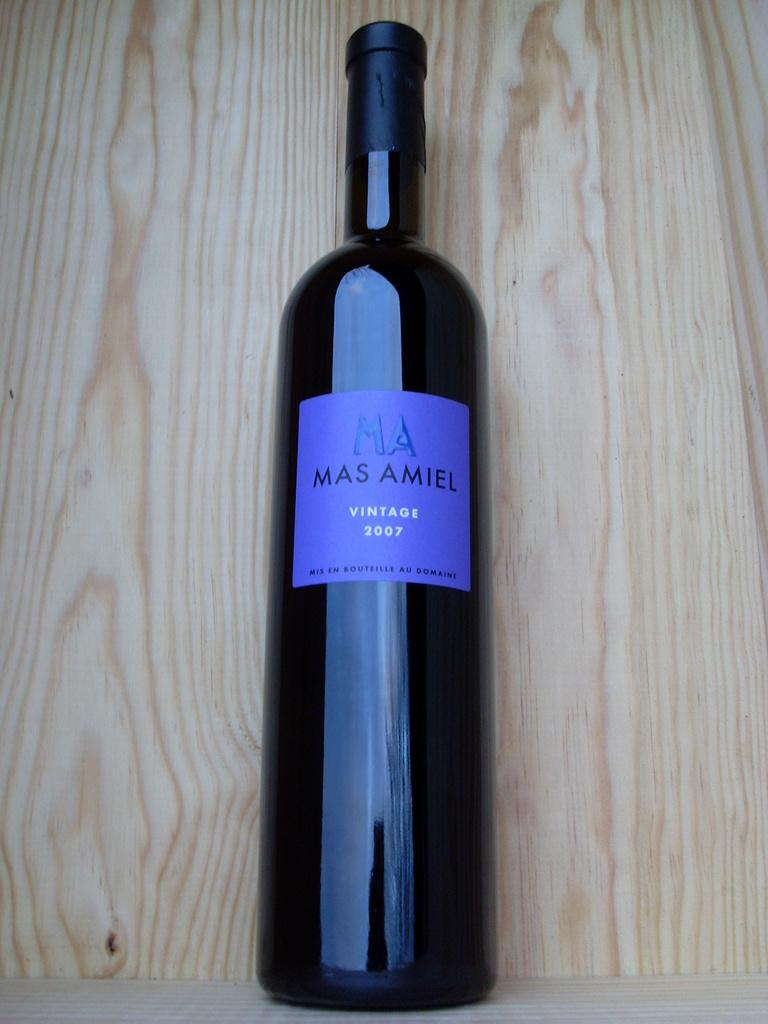<image>
Relay a brief, clear account of the picture shown. Mas Amiel 2007 is on a wooden shelf 